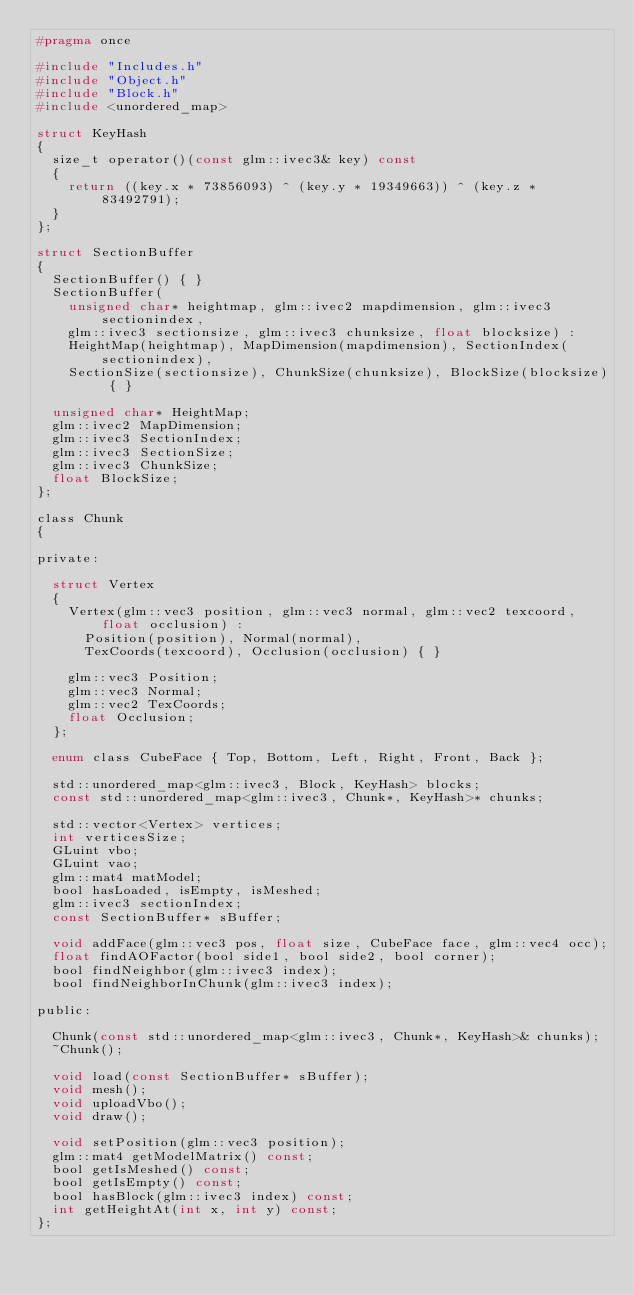Convert code to text. <code><loc_0><loc_0><loc_500><loc_500><_C_>#pragma once

#include "Includes.h"
#include "Object.h"
#include "Block.h"
#include <unordered_map>

struct KeyHash
{
	size_t operator()(const glm::ivec3& key) const
	{
		return ((key.x * 73856093) ^ (key.y * 19349663)) ^ (key.z * 83492791);
	}
};

struct SectionBuffer
{
	SectionBuffer() { }
	SectionBuffer(
		unsigned char* heightmap, glm::ivec2 mapdimension, glm::ivec3 sectionindex, 
		glm::ivec3 sectionsize, glm::ivec3 chunksize, float blocksize) :
		HeightMap(heightmap), MapDimension(mapdimension), SectionIndex(sectionindex), 
		SectionSize(sectionsize), ChunkSize(chunksize), BlockSize(blocksize) { }

	unsigned char* HeightMap;
	glm::ivec2 MapDimension;
	glm::ivec3 SectionIndex;
	glm::ivec3 SectionSize;
	glm::ivec3 ChunkSize;
	float BlockSize;
};

class Chunk
{

private:

	struct Vertex
	{
		Vertex(glm::vec3 position, glm::vec3 normal, glm::vec2 texcoord, float occlusion) :
			Position(position), Normal(normal), 
			TexCoords(texcoord), Occlusion(occlusion) { }

		glm::vec3 Position;
		glm::vec3 Normal;
		glm::vec2 TexCoords;
		float Occlusion;
	};

	enum class CubeFace { Top, Bottom, Left, Right, Front, Back };

	std::unordered_map<glm::ivec3, Block, KeyHash> blocks;
	const std::unordered_map<glm::ivec3, Chunk*, KeyHash>* chunks;

	std::vector<Vertex> vertices;
	int verticesSize;
	GLuint vbo;
	GLuint vao;
	glm::mat4 matModel;
	bool hasLoaded, isEmpty, isMeshed;
	glm::ivec3 sectionIndex;
	const SectionBuffer* sBuffer;

	void addFace(glm::vec3 pos, float size, CubeFace face, glm::vec4 occ);
	float findAOFactor(bool side1, bool side2, bool corner);
	bool findNeighbor(glm::ivec3 index);
	bool findNeighborInChunk(glm::ivec3 index);

public:

	Chunk(const std::unordered_map<glm::ivec3, Chunk*, KeyHash>& chunks);
	~Chunk();

	void load(const SectionBuffer* sBuffer);
	void mesh();
	void uploadVbo();
	void draw();

	void setPosition(glm::vec3 position);
	glm::mat4 getModelMatrix() const;
	bool getIsMeshed() const;
	bool getIsEmpty() const;
	bool hasBlock(glm::ivec3 index) const;
	int getHeightAt(int x, int y) const;
};</code> 